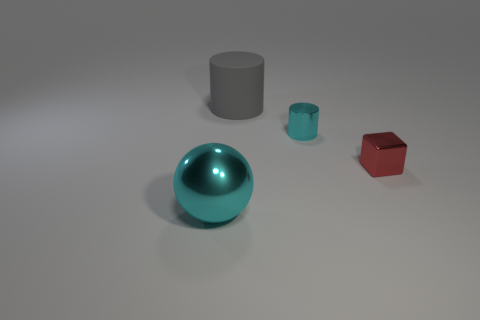Subtract all yellow cylinders. Subtract all green balls. How many cylinders are left? 2 Add 3 rubber cubes. How many objects exist? 7 Subtract all balls. How many objects are left? 3 Add 4 brown rubber balls. How many brown rubber balls exist? 4 Subtract 0 brown blocks. How many objects are left? 4 Subtract all tiny red blocks. Subtract all spheres. How many objects are left? 2 Add 2 large gray cylinders. How many large gray cylinders are left? 3 